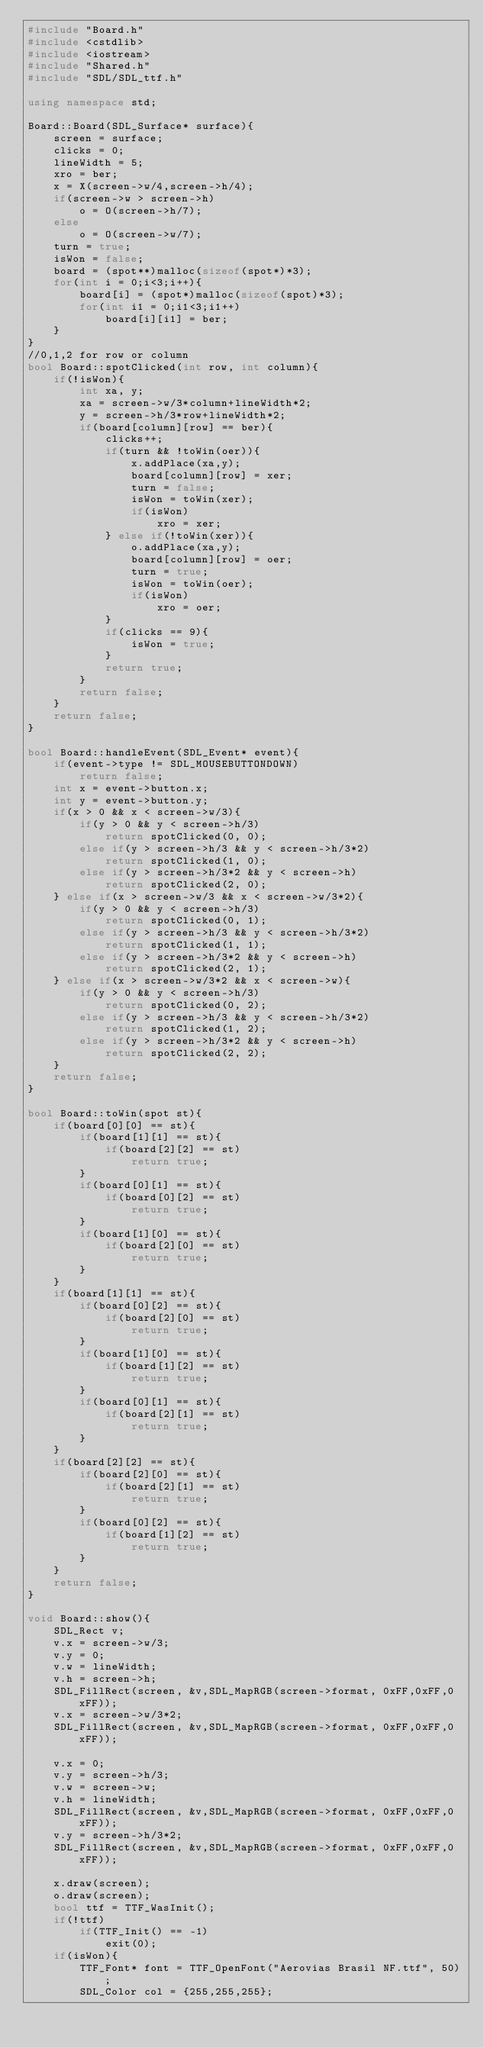<code> <loc_0><loc_0><loc_500><loc_500><_C++_>#include "Board.h"
#include <cstdlib>
#include <iostream>
#include "Shared.h"
#include "SDL/SDL_ttf.h"

using namespace std;

Board::Board(SDL_Surface* surface){
	screen = surface;
	clicks = 0;
	lineWidth = 5;
	xro = ber;
	x = X(screen->w/4,screen->h/4);
	if(screen->w > screen->h)
		o = O(screen->h/7);
	else
		o = O(screen->w/7);
	turn = true;
	isWon = false;
	board = (spot**)malloc(sizeof(spot*)*3);
	for(int i = 0;i<3;i++){
		board[i] = (spot*)malloc(sizeof(spot)*3);
		for(int i1 = 0;i1<3;i1++)
			board[i][i1] = ber;
	}
}
//0,1,2 for row or column
bool Board::spotClicked(int row, int column){
	if(!isWon){
		int xa, y;
		xa = screen->w/3*column+lineWidth*2;
		y = screen->h/3*row+lineWidth*2;
		if(board[column][row] == ber){
			clicks++;
			if(turn && !toWin(oer)){
				x.addPlace(xa,y);
				board[column][row] = xer;
				turn = false;
				isWon = toWin(xer);
				if(isWon)
					xro = xer;
			} else if(!toWin(xer)){
				o.addPlace(xa,y);
				board[column][row] = oer;
				turn = true;
				isWon = toWin(oer);
				if(isWon)
					xro = oer;
			}
			if(clicks == 9){
				isWon = true;
			}
			return true;
		}
		return false;
	}
	return false;
}

bool Board::handleEvent(SDL_Event* event){
	if(event->type != SDL_MOUSEBUTTONDOWN)
		return false;
	int x = event->button.x;
	int y = event->button.y;
	if(x > 0 && x < screen->w/3){
		if(y > 0 && y < screen->h/3)
			return spotClicked(0, 0);
		else if(y > screen->h/3 && y < screen->h/3*2)
			return spotClicked(1, 0);
		else if(y > screen->h/3*2 && y < screen->h)
			return spotClicked(2, 0);
	} else if(x > screen->w/3 && x < screen->w/3*2){
		if(y > 0 && y < screen->h/3)
			return spotClicked(0, 1);
		else if(y > screen->h/3 && y < screen->h/3*2)
			return spotClicked(1, 1);
		else if(y > screen->h/3*2 && y < screen->h)
			return spotClicked(2, 1);
	} else if(x > screen->w/3*2 && x < screen->w){
		if(y > 0 && y < screen->h/3)
			return spotClicked(0, 2);
		else if(y > screen->h/3 && y < screen->h/3*2)
			return spotClicked(1, 2);
		else if(y > screen->h/3*2 && y < screen->h)
			return spotClicked(2, 2);
	}
	return false;
}

bool Board::toWin(spot st){
	if(board[0][0] == st){
		if(board[1][1] == st){
			if(board[2][2] == st)
				return true;
		}
		if(board[0][1] == st){
			if(board[0][2] == st)
				return true;
		}
		if(board[1][0] == st){
			if(board[2][0] == st)
				return true;
		}
	}
	if(board[1][1] == st){
		if(board[0][2] == st){
			if(board[2][0] == st)
				return true;
		}
		if(board[1][0] == st){
			if(board[1][2] == st)
				return true;
		}
		if(board[0][1] == st){
			if(board[2][1] == st)
				return true;
		}
	}
	if(board[2][2] == st){
		if(board[2][0] == st){
			if(board[2][1] == st)
				return true;
		}
		if(board[0][2] == st){
			if(board[1][2] == st)
				return true;
		}
	}
	return false;
}

void Board::show(){
	SDL_Rect v;
	v.x = screen->w/3;
	v.y = 0;
	v.w = lineWidth;
	v.h = screen->h;
	SDL_FillRect(screen, &v,SDL_MapRGB(screen->format, 0xFF,0xFF,0xFF));
	v.x = screen->w/3*2;
	SDL_FillRect(screen, &v,SDL_MapRGB(screen->format, 0xFF,0xFF,0xFF));
	
	v.x = 0;
	v.y = screen->h/3;
	v.w = screen->w;
	v.h = lineWidth;
	SDL_FillRect(screen, &v,SDL_MapRGB(screen->format, 0xFF,0xFF,0xFF));
	v.y = screen->h/3*2;
	SDL_FillRect(screen, &v,SDL_MapRGB(screen->format, 0xFF,0xFF,0xFF));
	
	x.draw(screen);
	o.draw(screen);
	bool ttf = TTF_WasInit();
	if(!ttf)
		if(TTF_Init() == -1)
			exit(0);
	if(isWon){
		TTF_Font* font = TTF_OpenFont("Aerovias Brasil NF.ttf", 50);
		SDL_Color col = {255,255,255};</code> 